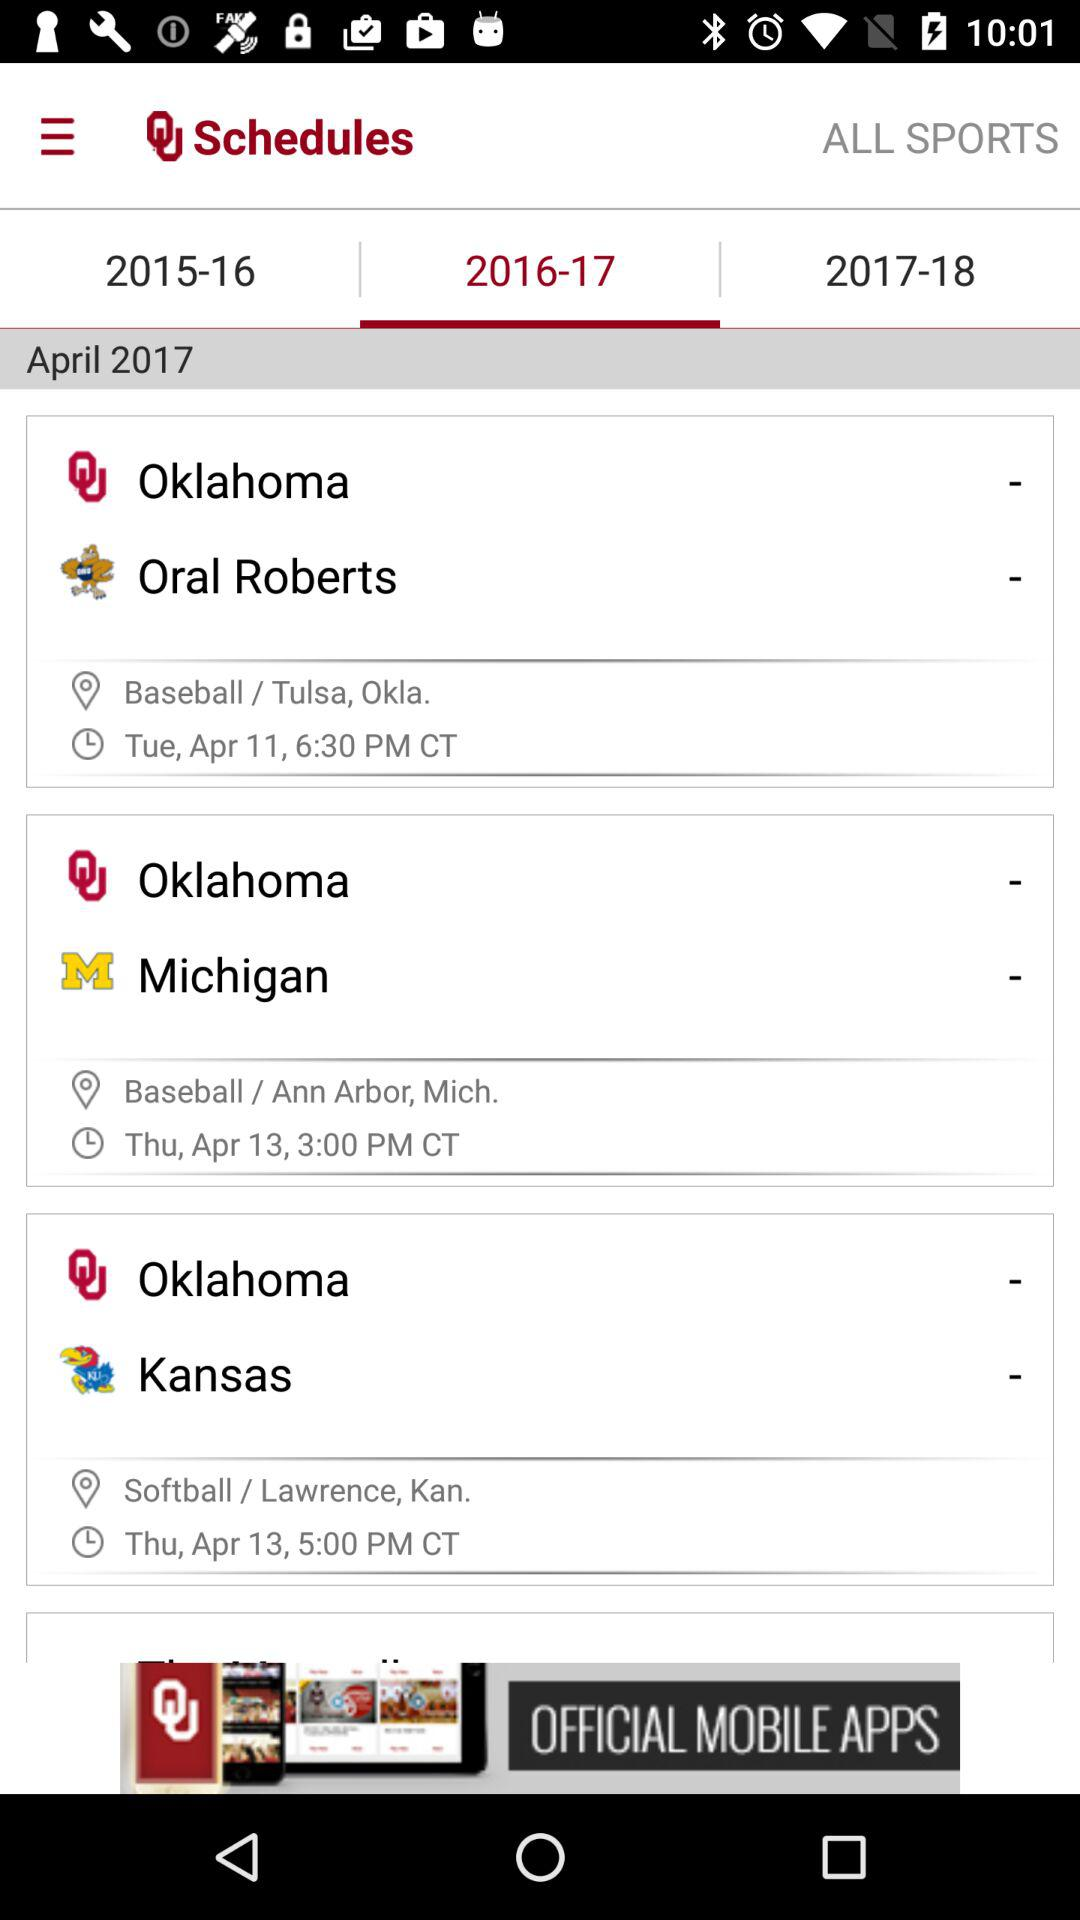How many games are for baseball?
Answer the question using a single word or phrase. 2 